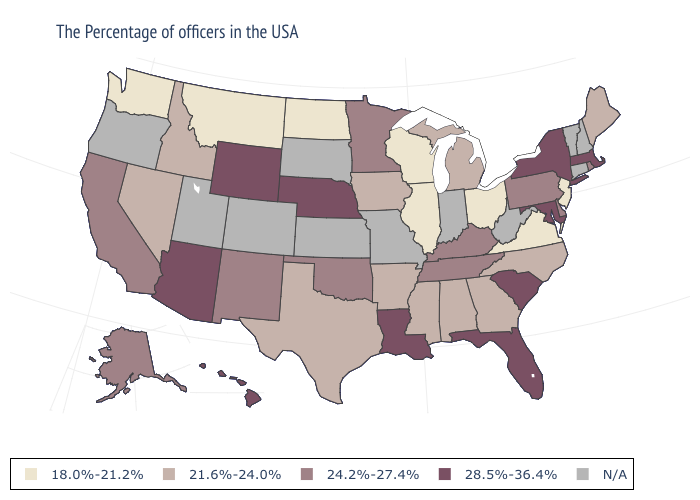Name the states that have a value in the range 24.2%-27.4%?
Be succinct. Rhode Island, Delaware, Pennsylvania, Kentucky, Tennessee, Minnesota, Oklahoma, New Mexico, California, Alaska. Is the legend a continuous bar?
Answer briefly. No. Does Massachusetts have the highest value in the Northeast?
Give a very brief answer. Yes. Among the states that border Wyoming , which have the highest value?
Concise answer only. Nebraska. What is the value of Vermont?
Short answer required. N/A. Does the map have missing data?
Give a very brief answer. Yes. What is the value of Washington?
Short answer required. 18.0%-21.2%. What is the value of Maine?
Keep it brief. 21.6%-24.0%. Name the states that have a value in the range 28.5%-36.4%?
Short answer required. Massachusetts, New York, Maryland, South Carolina, Florida, Louisiana, Nebraska, Wyoming, Arizona, Hawaii. What is the highest value in the USA?
Keep it brief. 28.5%-36.4%. Name the states that have a value in the range 28.5%-36.4%?
Be succinct. Massachusetts, New York, Maryland, South Carolina, Florida, Louisiana, Nebraska, Wyoming, Arizona, Hawaii. What is the value of New York?
Give a very brief answer. 28.5%-36.4%. 